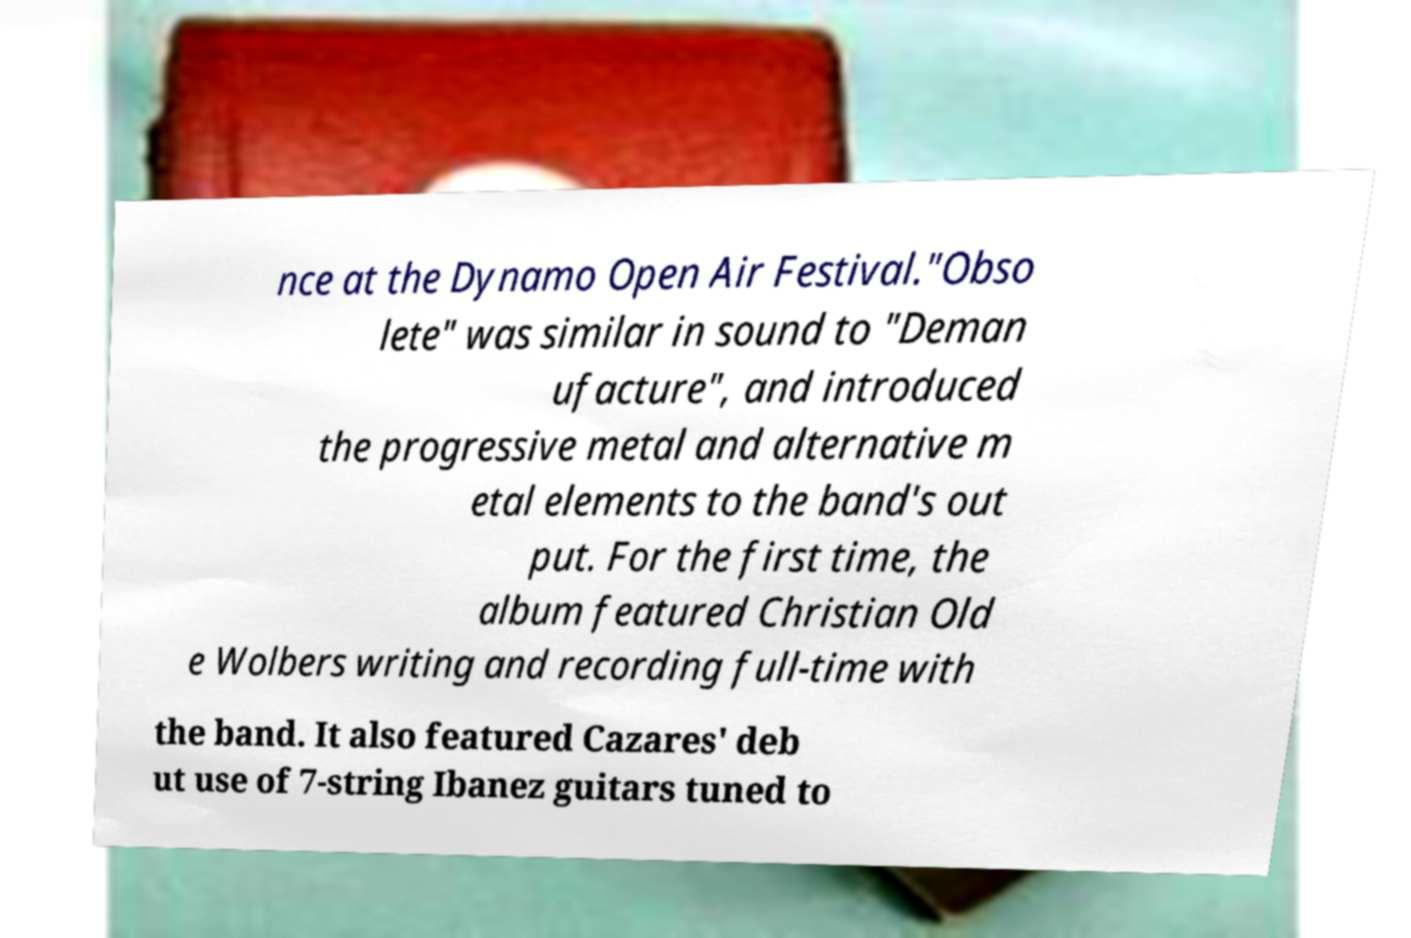Could you extract and type out the text from this image? nce at the Dynamo Open Air Festival."Obso lete" was similar in sound to "Deman ufacture", and introduced the progressive metal and alternative m etal elements to the band's out put. For the first time, the album featured Christian Old e Wolbers writing and recording full-time with the band. It also featured Cazares' deb ut use of 7-string Ibanez guitars tuned to 